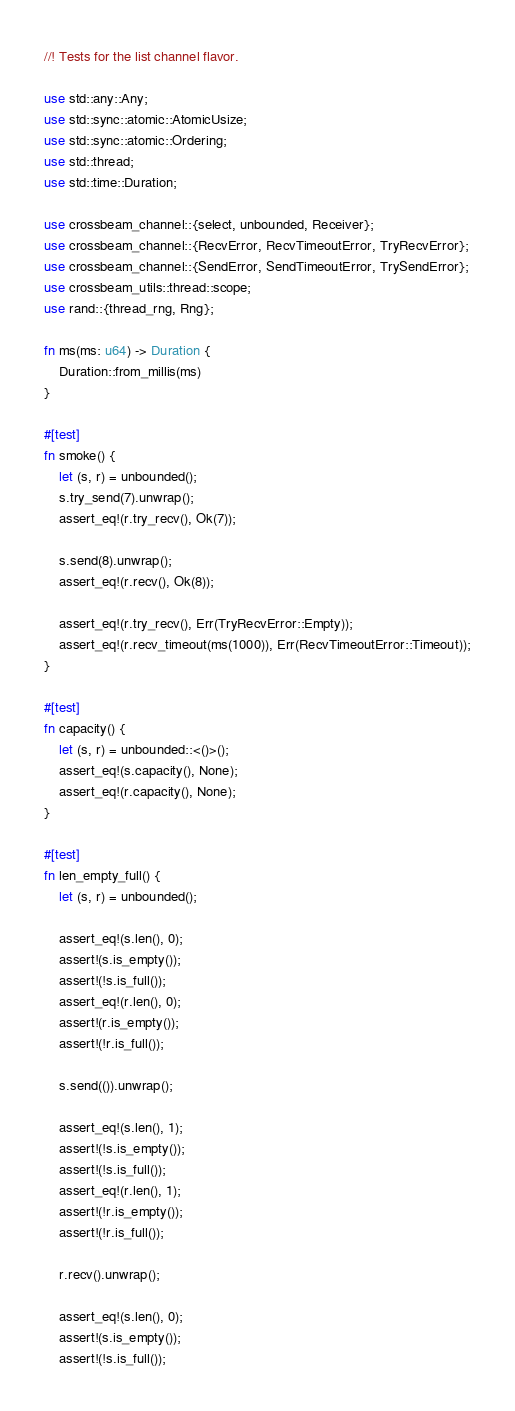<code> <loc_0><loc_0><loc_500><loc_500><_Rust_>//! Tests for the list channel flavor.

use std::any::Any;
use std::sync::atomic::AtomicUsize;
use std::sync::atomic::Ordering;
use std::thread;
use std::time::Duration;

use crossbeam_channel::{select, unbounded, Receiver};
use crossbeam_channel::{RecvError, RecvTimeoutError, TryRecvError};
use crossbeam_channel::{SendError, SendTimeoutError, TrySendError};
use crossbeam_utils::thread::scope;
use rand::{thread_rng, Rng};

fn ms(ms: u64) -> Duration {
    Duration::from_millis(ms)
}

#[test]
fn smoke() {
    let (s, r) = unbounded();
    s.try_send(7).unwrap();
    assert_eq!(r.try_recv(), Ok(7));

    s.send(8).unwrap();
    assert_eq!(r.recv(), Ok(8));

    assert_eq!(r.try_recv(), Err(TryRecvError::Empty));
    assert_eq!(r.recv_timeout(ms(1000)), Err(RecvTimeoutError::Timeout));
}

#[test]
fn capacity() {
    let (s, r) = unbounded::<()>();
    assert_eq!(s.capacity(), None);
    assert_eq!(r.capacity(), None);
}

#[test]
fn len_empty_full() {
    let (s, r) = unbounded();

    assert_eq!(s.len(), 0);
    assert!(s.is_empty());
    assert!(!s.is_full());
    assert_eq!(r.len(), 0);
    assert!(r.is_empty());
    assert!(!r.is_full());

    s.send(()).unwrap();

    assert_eq!(s.len(), 1);
    assert!(!s.is_empty());
    assert!(!s.is_full());
    assert_eq!(r.len(), 1);
    assert!(!r.is_empty());
    assert!(!r.is_full());

    r.recv().unwrap();

    assert_eq!(s.len(), 0);
    assert!(s.is_empty());
    assert!(!s.is_full());</code> 